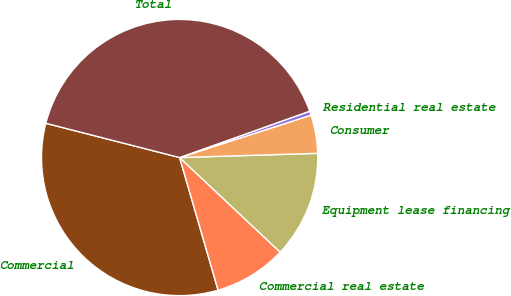<chart> <loc_0><loc_0><loc_500><loc_500><pie_chart><fcel>Commercial<fcel>Commercial real estate<fcel>Equipment lease financing<fcel>Consumer<fcel>Residential real estate<fcel>Total<nl><fcel>33.48%<fcel>8.49%<fcel>12.5%<fcel>4.48%<fcel>0.48%<fcel>40.56%<nl></chart> 